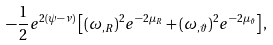Convert formula to latex. <formula><loc_0><loc_0><loc_500><loc_500>- \frac { 1 } { 2 } e ^ { 2 ( \psi - \nu ) } \left [ ( \omega _ { , R } ) ^ { 2 } e ^ { - 2 \mu _ { R } } + ( \omega _ { , \vartheta } ) ^ { 2 } e ^ { - 2 \mu _ { \vartheta } } \right ] ,</formula> 